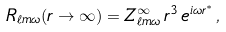<formula> <loc_0><loc_0><loc_500><loc_500>R _ { \ell m \omega } ( r \rightarrow \infty ) = Z ^ { \infty } _ { \ell m \omega } \, r ^ { 3 } \, e ^ { i \omega r ^ { * } } \, ,</formula> 